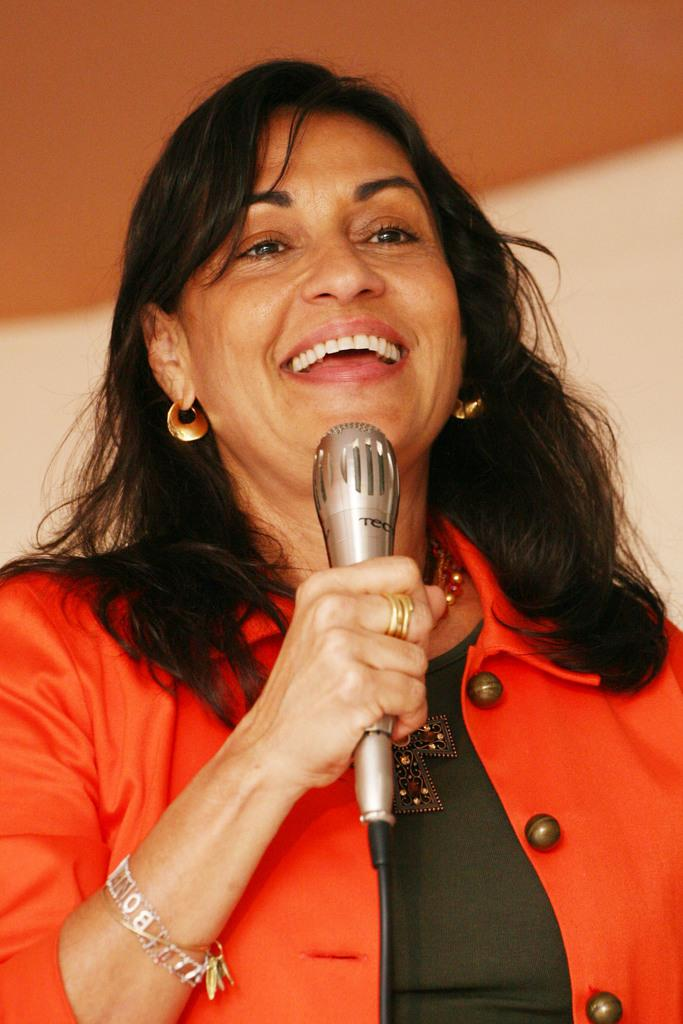What is the main subject of the image? The main subject of the image is a woman. What is the woman holding in her hand? The woman is holding a microphone in her hand. What expression does the woman have on her face? The woman is smiling. How would you describe the background of the image? The background of the image is blurred. What color is the woman wearing? The woman is wearing red color clothes. How many pages can be seen in the image? There are no pages present in the image. 